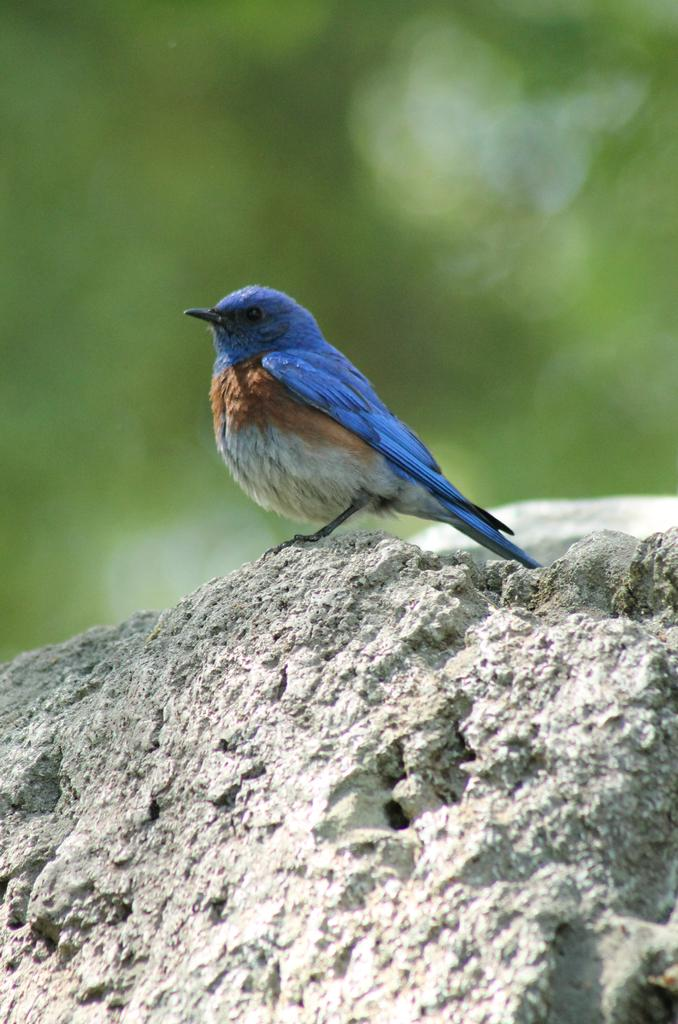What type of animal is in the image? There is a bird in the image. Where is the bird located? The bird is on a rock. Can you describe the background of the image? The background of the image is blurred. What type of bulb is hanging from the bird's beak in the image? There is no bulb present in the image, and the bird's beak is not holding anything. 